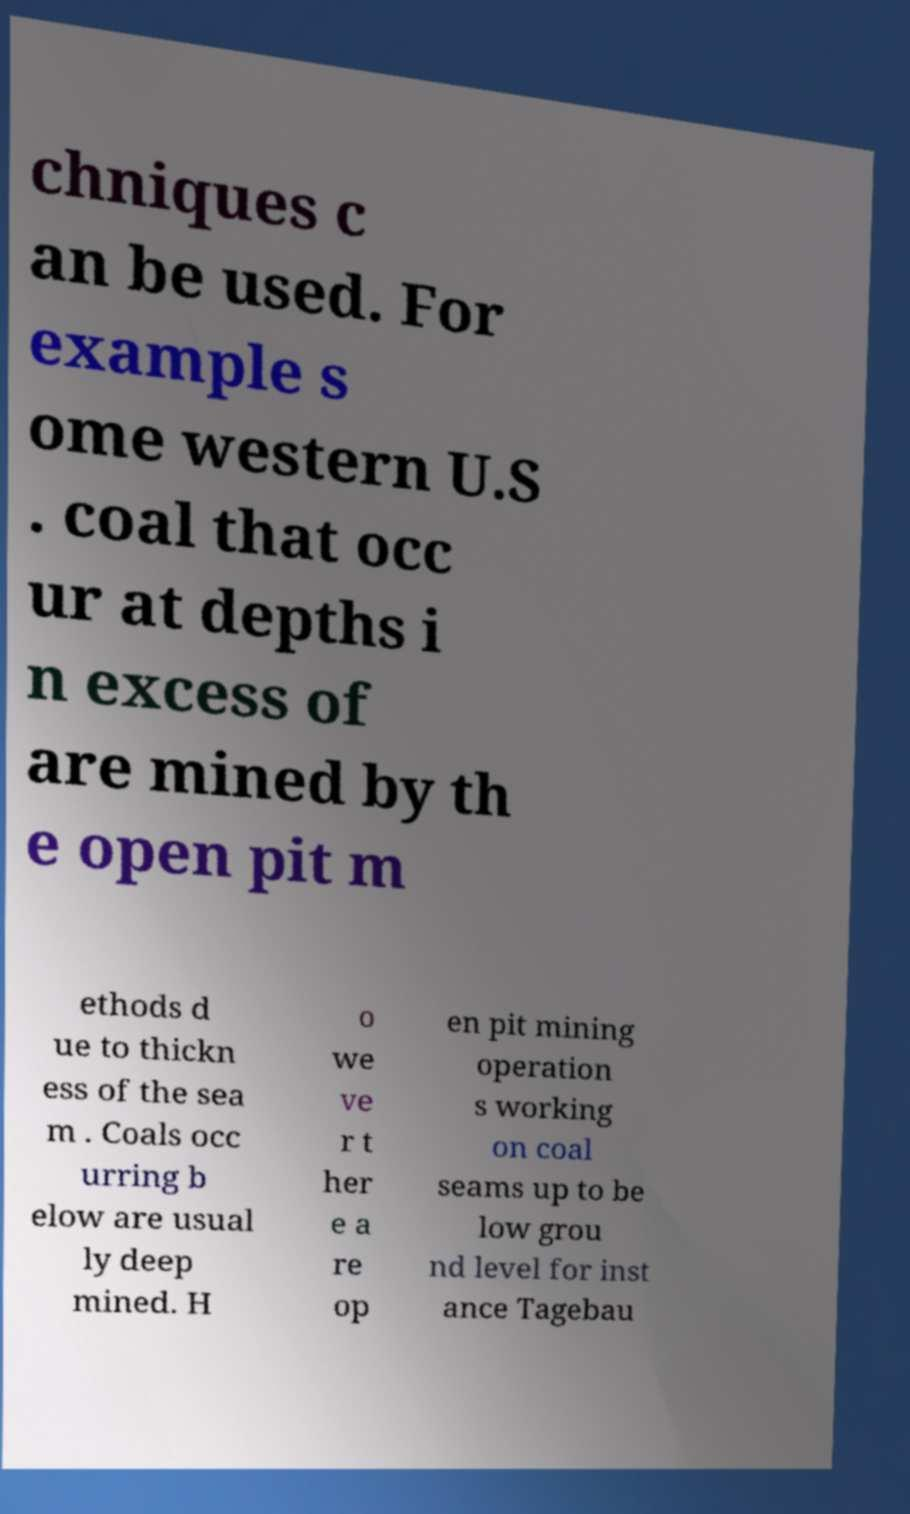Can you read and provide the text displayed in the image?This photo seems to have some interesting text. Can you extract and type it out for me? chniques c an be used. For example s ome western U.S . coal that occ ur at depths i n excess of are mined by th e open pit m ethods d ue to thickn ess of the sea m . Coals occ urring b elow are usual ly deep mined. H o we ve r t her e a re op en pit mining operation s working on coal seams up to be low grou nd level for inst ance Tagebau 